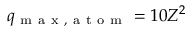<formula> <loc_0><loc_0><loc_500><loc_500>q _ { m a x , a t o m } = 1 0 Z ^ { 2 }</formula> 